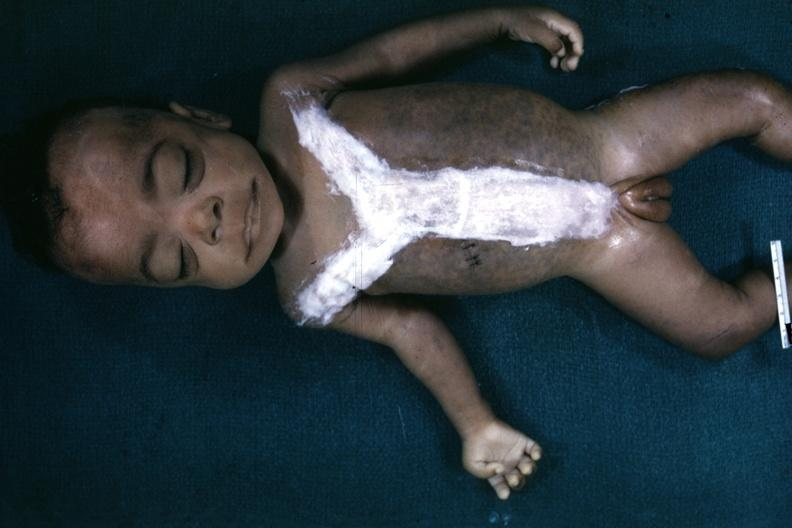what is whole body after autopsy with covered incision very good representation of mongoloid facies and one hand opened quite good example?
Answer the question using a single word or phrase. Opened to show simian crease 